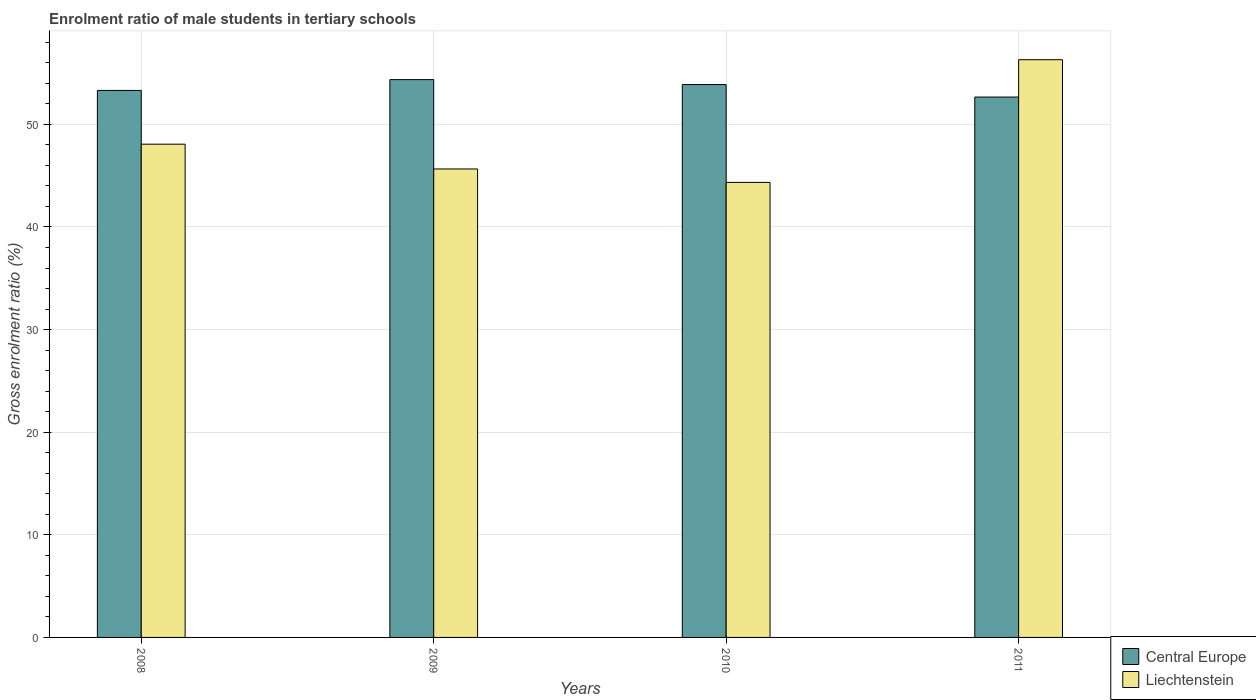How many groups of bars are there?
Keep it short and to the point. 4. In how many cases, is the number of bars for a given year not equal to the number of legend labels?
Make the answer very short. 0. What is the enrolment ratio of male students in tertiary schools in Liechtenstein in 2010?
Your response must be concise. 44.34. Across all years, what is the maximum enrolment ratio of male students in tertiary schools in Central Europe?
Provide a short and direct response. 54.36. Across all years, what is the minimum enrolment ratio of male students in tertiary schools in Liechtenstein?
Offer a very short reply. 44.34. In which year was the enrolment ratio of male students in tertiary schools in Liechtenstein minimum?
Provide a succinct answer. 2010. What is the total enrolment ratio of male students in tertiary schools in Liechtenstein in the graph?
Keep it short and to the point. 194.38. What is the difference between the enrolment ratio of male students in tertiary schools in Liechtenstein in 2009 and that in 2010?
Your answer should be compact. 1.31. What is the difference between the enrolment ratio of male students in tertiary schools in Liechtenstein in 2008 and the enrolment ratio of male students in tertiary schools in Central Europe in 2010?
Your answer should be very brief. -5.81. What is the average enrolment ratio of male students in tertiary schools in Liechtenstein per year?
Provide a succinct answer. 48.59. In the year 2009, what is the difference between the enrolment ratio of male students in tertiary schools in Liechtenstein and enrolment ratio of male students in tertiary schools in Central Europe?
Provide a short and direct response. -8.71. What is the ratio of the enrolment ratio of male students in tertiary schools in Liechtenstein in 2008 to that in 2010?
Your response must be concise. 1.08. Is the difference between the enrolment ratio of male students in tertiary schools in Liechtenstein in 2008 and 2011 greater than the difference between the enrolment ratio of male students in tertiary schools in Central Europe in 2008 and 2011?
Keep it short and to the point. No. What is the difference between the highest and the second highest enrolment ratio of male students in tertiary schools in Liechtenstein?
Give a very brief answer. 8.23. What is the difference between the highest and the lowest enrolment ratio of male students in tertiary schools in Central Europe?
Offer a terse response. 1.7. What does the 1st bar from the left in 2009 represents?
Offer a very short reply. Central Europe. What does the 2nd bar from the right in 2011 represents?
Give a very brief answer. Central Europe. Are all the bars in the graph horizontal?
Your answer should be compact. No. Does the graph contain any zero values?
Your response must be concise. No. Where does the legend appear in the graph?
Give a very brief answer. Bottom right. What is the title of the graph?
Offer a terse response. Enrolment ratio of male students in tertiary schools. Does "Mexico" appear as one of the legend labels in the graph?
Provide a succinct answer. No. What is the label or title of the Y-axis?
Your response must be concise. Gross enrolment ratio (%). What is the Gross enrolment ratio (%) of Central Europe in 2008?
Offer a very short reply. 53.31. What is the Gross enrolment ratio (%) in Liechtenstein in 2008?
Offer a very short reply. 48.07. What is the Gross enrolment ratio (%) in Central Europe in 2009?
Provide a short and direct response. 54.36. What is the Gross enrolment ratio (%) of Liechtenstein in 2009?
Offer a terse response. 45.66. What is the Gross enrolment ratio (%) of Central Europe in 2010?
Your answer should be very brief. 53.88. What is the Gross enrolment ratio (%) in Liechtenstein in 2010?
Provide a short and direct response. 44.34. What is the Gross enrolment ratio (%) in Central Europe in 2011?
Ensure brevity in your answer.  52.66. What is the Gross enrolment ratio (%) in Liechtenstein in 2011?
Provide a succinct answer. 56.3. Across all years, what is the maximum Gross enrolment ratio (%) of Central Europe?
Offer a terse response. 54.36. Across all years, what is the maximum Gross enrolment ratio (%) in Liechtenstein?
Make the answer very short. 56.3. Across all years, what is the minimum Gross enrolment ratio (%) in Central Europe?
Give a very brief answer. 52.66. Across all years, what is the minimum Gross enrolment ratio (%) of Liechtenstein?
Make the answer very short. 44.34. What is the total Gross enrolment ratio (%) in Central Europe in the graph?
Ensure brevity in your answer.  214.22. What is the total Gross enrolment ratio (%) in Liechtenstein in the graph?
Your response must be concise. 194.38. What is the difference between the Gross enrolment ratio (%) of Central Europe in 2008 and that in 2009?
Offer a very short reply. -1.05. What is the difference between the Gross enrolment ratio (%) of Liechtenstein in 2008 and that in 2009?
Your answer should be compact. 2.42. What is the difference between the Gross enrolment ratio (%) in Central Europe in 2008 and that in 2010?
Make the answer very short. -0.57. What is the difference between the Gross enrolment ratio (%) in Liechtenstein in 2008 and that in 2010?
Your answer should be very brief. 3.73. What is the difference between the Gross enrolment ratio (%) of Central Europe in 2008 and that in 2011?
Ensure brevity in your answer.  0.65. What is the difference between the Gross enrolment ratio (%) of Liechtenstein in 2008 and that in 2011?
Make the answer very short. -8.23. What is the difference between the Gross enrolment ratio (%) of Central Europe in 2009 and that in 2010?
Make the answer very short. 0.48. What is the difference between the Gross enrolment ratio (%) of Liechtenstein in 2009 and that in 2010?
Provide a succinct answer. 1.31. What is the difference between the Gross enrolment ratio (%) in Central Europe in 2009 and that in 2011?
Your answer should be compact. 1.7. What is the difference between the Gross enrolment ratio (%) in Liechtenstein in 2009 and that in 2011?
Make the answer very short. -10.65. What is the difference between the Gross enrolment ratio (%) of Central Europe in 2010 and that in 2011?
Ensure brevity in your answer.  1.22. What is the difference between the Gross enrolment ratio (%) in Liechtenstein in 2010 and that in 2011?
Offer a terse response. -11.96. What is the difference between the Gross enrolment ratio (%) of Central Europe in 2008 and the Gross enrolment ratio (%) of Liechtenstein in 2009?
Provide a short and direct response. 7.65. What is the difference between the Gross enrolment ratio (%) of Central Europe in 2008 and the Gross enrolment ratio (%) of Liechtenstein in 2010?
Ensure brevity in your answer.  8.96. What is the difference between the Gross enrolment ratio (%) in Central Europe in 2008 and the Gross enrolment ratio (%) in Liechtenstein in 2011?
Make the answer very short. -2.99. What is the difference between the Gross enrolment ratio (%) in Central Europe in 2009 and the Gross enrolment ratio (%) in Liechtenstein in 2010?
Provide a succinct answer. 10.02. What is the difference between the Gross enrolment ratio (%) of Central Europe in 2009 and the Gross enrolment ratio (%) of Liechtenstein in 2011?
Your response must be concise. -1.94. What is the difference between the Gross enrolment ratio (%) of Central Europe in 2010 and the Gross enrolment ratio (%) of Liechtenstein in 2011?
Keep it short and to the point. -2.42. What is the average Gross enrolment ratio (%) of Central Europe per year?
Offer a very short reply. 53.55. What is the average Gross enrolment ratio (%) in Liechtenstein per year?
Your response must be concise. 48.59. In the year 2008, what is the difference between the Gross enrolment ratio (%) of Central Europe and Gross enrolment ratio (%) of Liechtenstein?
Ensure brevity in your answer.  5.24. In the year 2009, what is the difference between the Gross enrolment ratio (%) of Central Europe and Gross enrolment ratio (%) of Liechtenstein?
Provide a short and direct response. 8.71. In the year 2010, what is the difference between the Gross enrolment ratio (%) of Central Europe and Gross enrolment ratio (%) of Liechtenstein?
Your answer should be compact. 9.54. In the year 2011, what is the difference between the Gross enrolment ratio (%) in Central Europe and Gross enrolment ratio (%) in Liechtenstein?
Keep it short and to the point. -3.64. What is the ratio of the Gross enrolment ratio (%) of Central Europe in 2008 to that in 2009?
Keep it short and to the point. 0.98. What is the ratio of the Gross enrolment ratio (%) of Liechtenstein in 2008 to that in 2009?
Ensure brevity in your answer.  1.05. What is the ratio of the Gross enrolment ratio (%) in Central Europe in 2008 to that in 2010?
Make the answer very short. 0.99. What is the ratio of the Gross enrolment ratio (%) of Liechtenstein in 2008 to that in 2010?
Offer a very short reply. 1.08. What is the ratio of the Gross enrolment ratio (%) in Central Europe in 2008 to that in 2011?
Your answer should be compact. 1.01. What is the ratio of the Gross enrolment ratio (%) in Liechtenstein in 2008 to that in 2011?
Make the answer very short. 0.85. What is the ratio of the Gross enrolment ratio (%) in Central Europe in 2009 to that in 2010?
Your answer should be compact. 1.01. What is the ratio of the Gross enrolment ratio (%) of Liechtenstein in 2009 to that in 2010?
Provide a succinct answer. 1.03. What is the ratio of the Gross enrolment ratio (%) in Central Europe in 2009 to that in 2011?
Offer a terse response. 1.03. What is the ratio of the Gross enrolment ratio (%) in Liechtenstein in 2009 to that in 2011?
Ensure brevity in your answer.  0.81. What is the ratio of the Gross enrolment ratio (%) of Central Europe in 2010 to that in 2011?
Your response must be concise. 1.02. What is the ratio of the Gross enrolment ratio (%) in Liechtenstein in 2010 to that in 2011?
Make the answer very short. 0.79. What is the difference between the highest and the second highest Gross enrolment ratio (%) in Central Europe?
Your response must be concise. 0.48. What is the difference between the highest and the second highest Gross enrolment ratio (%) in Liechtenstein?
Provide a short and direct response. 8.23. What is the difference between the highest and the lowest Gross enrolment ratio (%) in Central Europe?
Your answer should be compact. 1.7. What is the difference between the highest and the lowest Gross enrolment ratio (%) in Liechtenstein?
Provide a succinct answer. 11.96. 